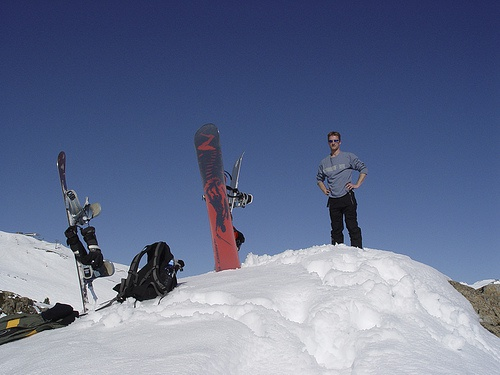Describe the objects in this image and their specific colors. I can see snowboard in navy, brown, black, gray, and purple tones, snowboard in navy, black, gray, and darkgray tones, people in navy, black, and gray tones, backpack in navy, black, gray, and darkgray tones, and backpack in navy, black, and gray tones in this image. 